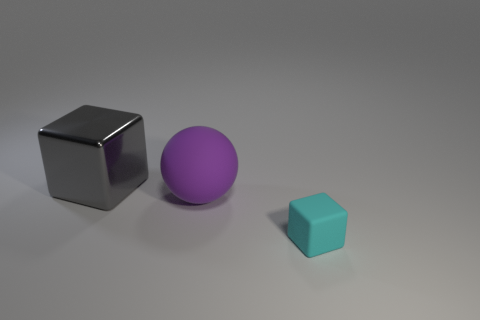Add 1 green cubes. How many objects exist? 4 Subtract all spheres. How many objects are left? 2 Add 1 large blocks. How many large blocks exist? 2 Subtract 1 purple spheres. How many objects are left? 2 Subtract all gray things. Subtract all gray objects. How many objects are left? 1 Add 3 tiny cyan blocks. How many tiny cyan blocks are left? 4 